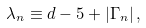<formula> <loc_0><loc_0><loc_500><loc_500>\lambda _ { n } \equiv d - 5 + | \Gamma _ { n } | \, ,</formula> 